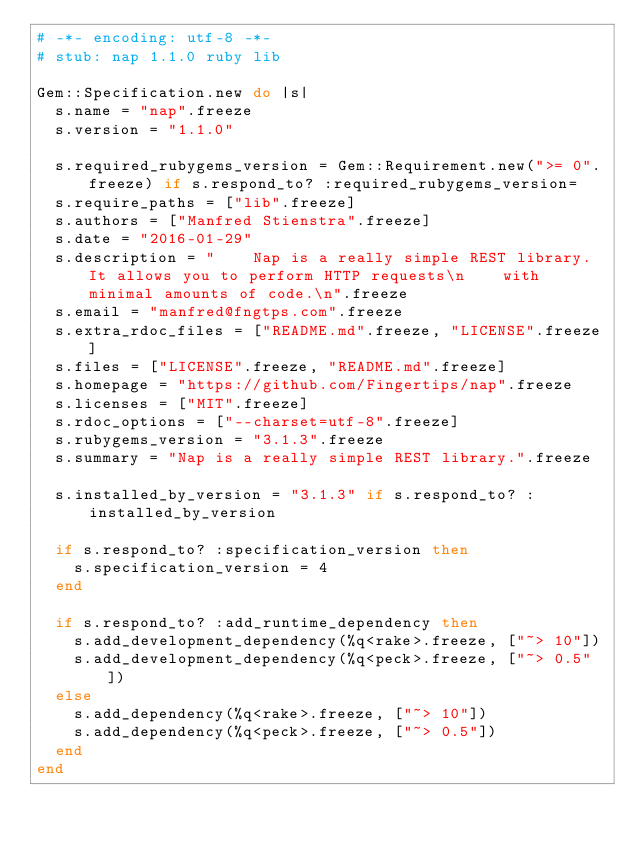Convert code to text. <code><loc_0><loc_0><loc_500><loc_500><_Ruby_># -*- encoding: utf-8 -*-
# stub: nap 1.1.0 ruby lib

Gem::Specification.new do |s|
  s.name = "nap".freeze
  s.version = "1.1.0"

  s.required_rubygems_version = Gem::Requirement.new(">= 0".freeze) if s.respond_to? :required_rubygems_version=
  s.require_paths = ["lib".freeze]
  s.authors = ["Manfred Stienstra".freeze]
  s.date = "2016-01-29"
  s.description = "    Nap is a really simple REST library. It allows you to perform HTTP requests\n    with minimal amounts of code.\n".freeze
  s.email = "manfred@fngtps.com".freeze
  s.extra_rdoc_files = ["README.md".freeze, "LICENSE".freeze]
  s.files = ["LICENSE".freeze, "README.md".freeze]
  s.homepage = "https://github.com/Fingertips/nap".freeze
  s.licenses = ["MIT".freeze]
  s.rdoc_options = ["--charset=utf-8".freeze]
  s.rubygems_version = "3.1.3".freeze
  s.summary = "Nap is a really simple REST library.".freeze

  s.installed_by_version = "3.1.3" if s.respond_to? :installed_by_version

  if s.respond_to? :specification_version then
    s.specification_version = 4
  end

  if s.respond_to? :add_runtime_dependency then
    s.add_development_dependency(%q<rake>.freeze, ["~> 10"])
    s.add_development_dependency(%q<peck>.freeze, ["~> 0.5"])
  else
    s.add_dependency(%q<rake>.freeze, ["~> 10"])
    s.add_dependency(%q<peck>.freeze, ["~> 0.5"])
  end
end
</code> 